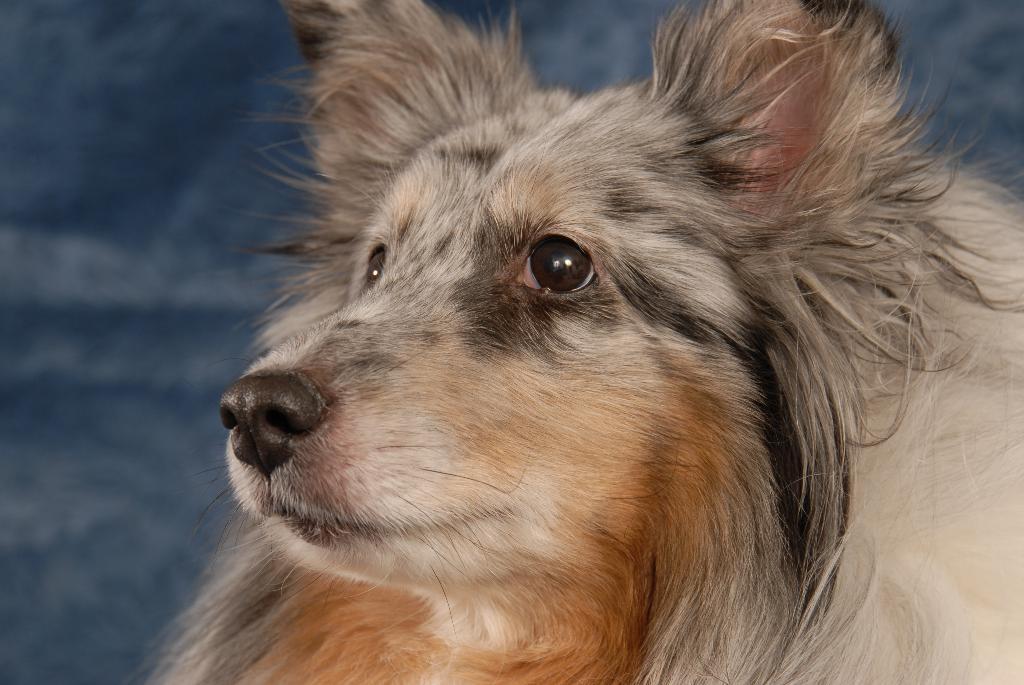Please provide a concise description of this image. There is an animal in black, brown and white color combination. In the background, there are some objects. 